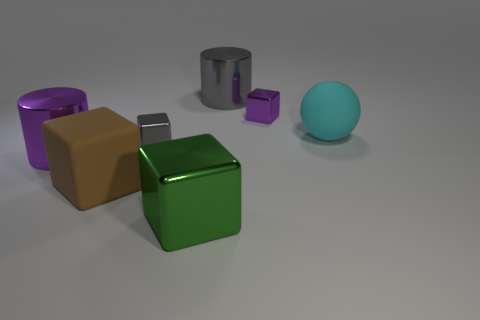There is a large cylinder in front of the small shiny thing right of the large gray cylinder; what color is it? The large cylinder in front of the small shiny object to the right of the gray cylinder is purple. This purple cylinder, with its vivid color and cylindrical shape, adds a touch of variety to the collection of objects presented. 